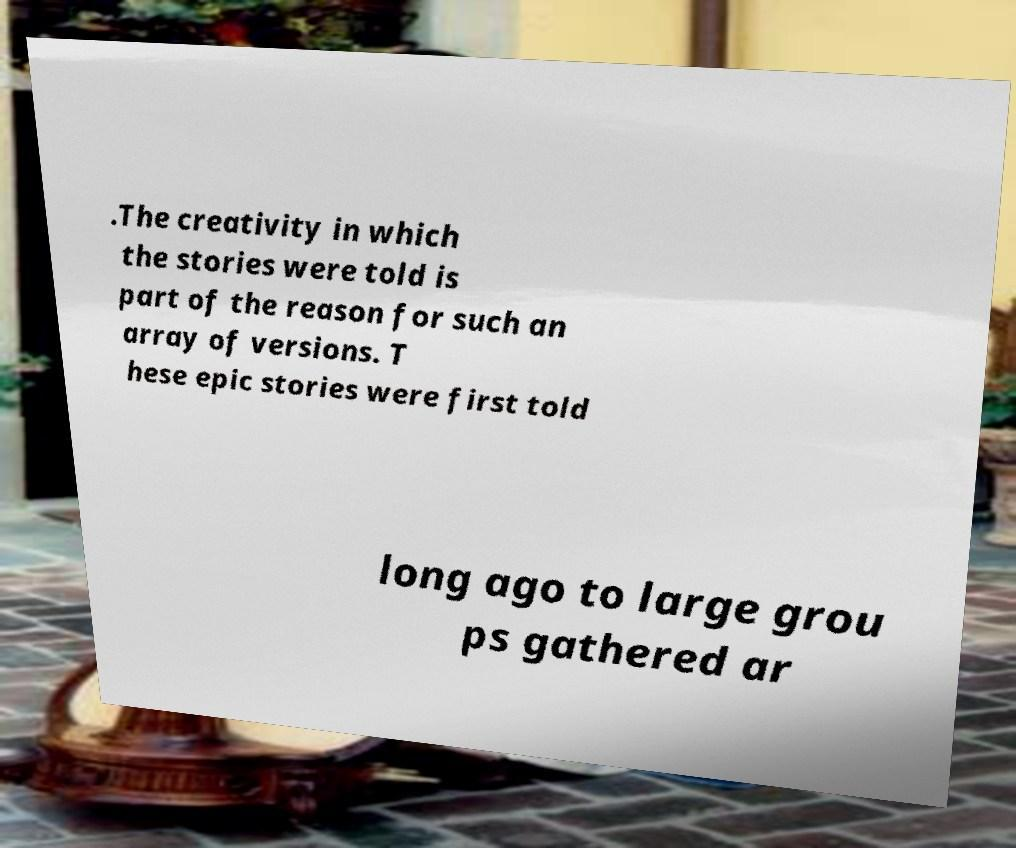What messages or text are displayed in this image? I need them in a readable, typed format. .The creativity in which the stories were told is part of the reason for such an array of versions. T hese epic stories were first told long ago to large grou ps gathered ar 